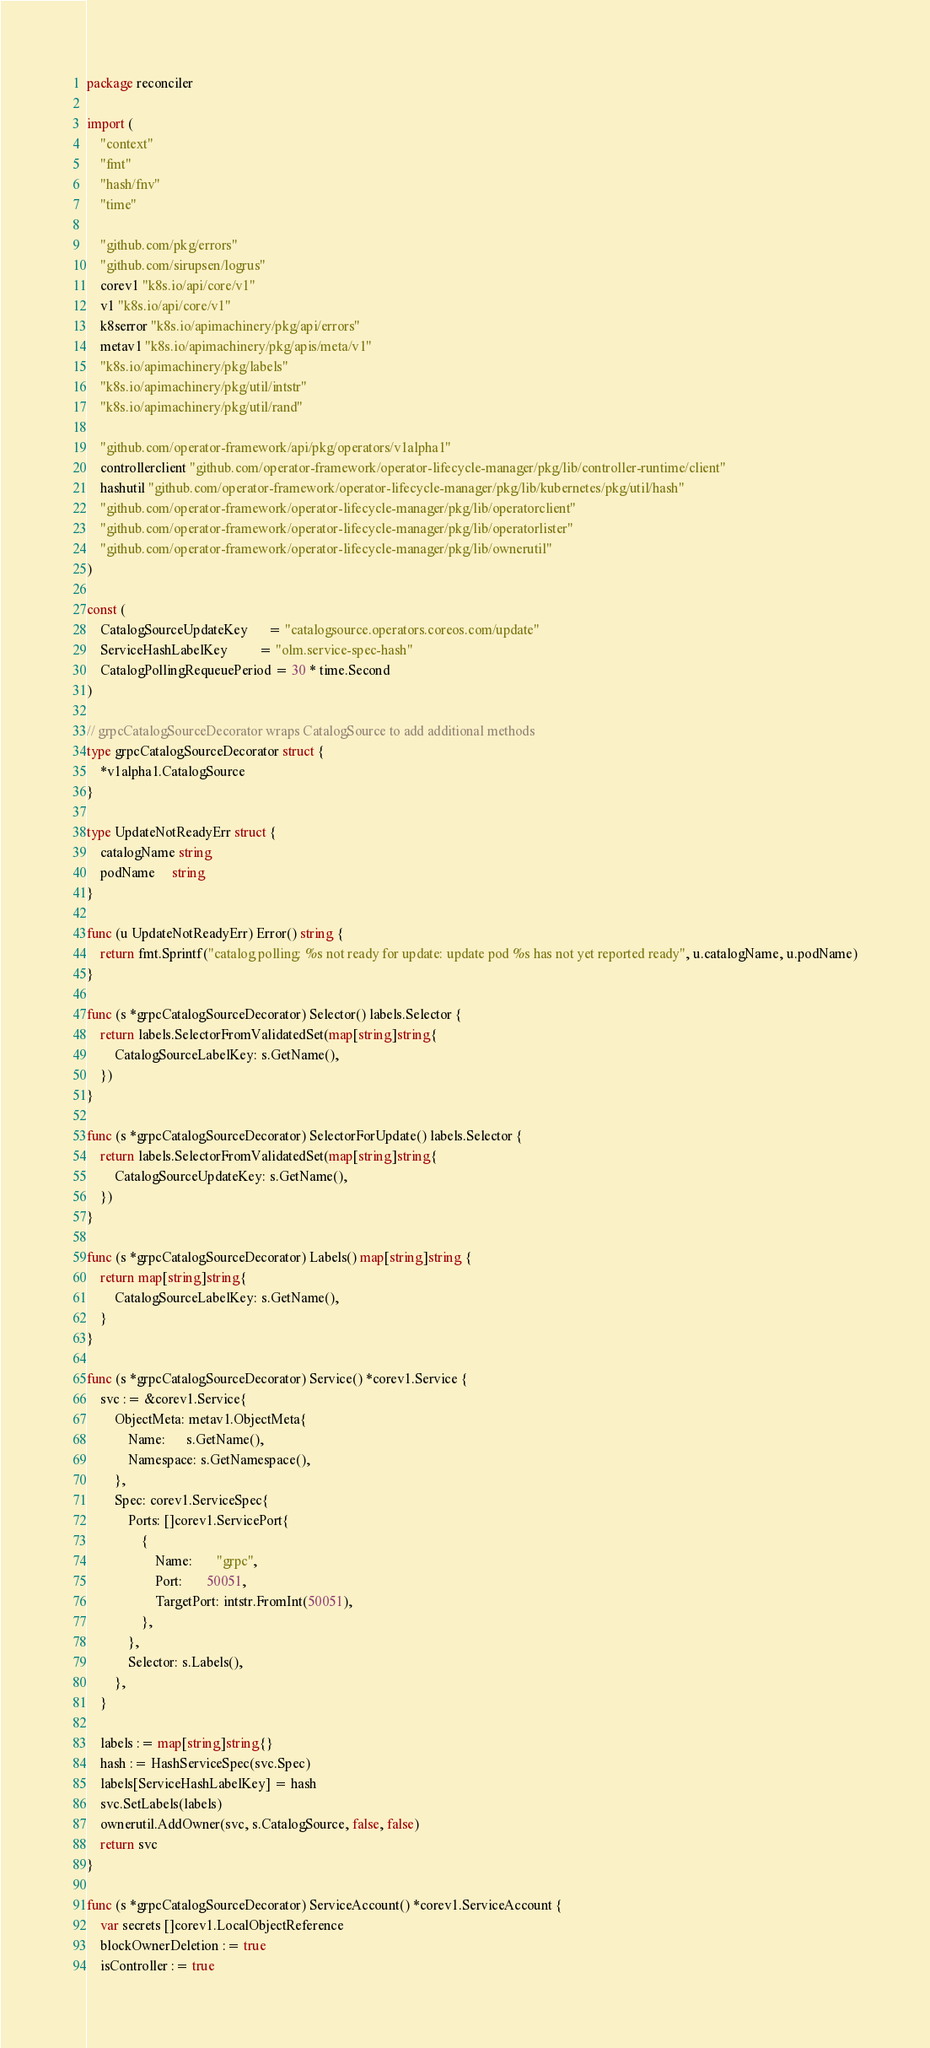<code> <loc_0><loc_0><loc_500><loc_500><_Go_>package reconciler

import (
	"context"
	"fmt"
	"hash/fnv"
	"time"

	"github.com/pkg/errors"
	"github.com/sirupsen/logrus"
	corev1 "k8s.io/api/core/v1"
	v1 "k8s.io/api/core/v1"
	k8serror "k8s.io/apimachinery/pkg/api/errors"
	metav1 "k8s.io/apimachinery/pkg/apis/meta/v1"
	"k8s.io/apimachinery/pkg/labels"
	"k8s.io/apimachinery/pkg/util/intstr"
	"k8s.io/apimachinery/pkg/util/rand"

	"github.com/operator-framework/api/pkg/operators/v1alpha1"
	controllerclient "github.com/operator-framework/operator-lifecycle-manager/pkg/lib/controller-runtime/client"
	hashutil "github.com/operator-framework/operator-lifecycle-manager/pkg/lib/kubernetes/pkg/util/hash"
	"github.com/operator-framework/operator-lifecycle-manager/pkg/lib/operatorclient"
	"github.com/operator-framework/operator-lifecycle-manager/pkg/lib/operatorlister"
	"github.com/operator-framework/operator-lifecycle-manager/pkg/lib/ownerutil"
)

const (
	CatalogSourceUpdateKey      = "catalogsource.operators.coreos.com/update"
	ServiceHashLabelKey         = "olm.service-spec-hash"
	CatalogPollingRequeuePeriod = 30 * time.Second
)

// grpcCatalogSourceDecorator wraps CatalogSource to add additional methods
type grpcCatalogSourceDecorator struct {
	*v1alpha1.CatalogSource
}

type UpdateNotReadyErr struct {
	catalogName string
	podName     string
}

func (u UpdateNotReadyErr) Error() string {
	return fmt.Sprintf("catalog polling: %s not ready for update: update pod %s has not yet reported ready", u.catalogName, u.podName)
}

func (s *grpcCatalogSourceDecorator) Selector() labels.Selector {
	return labels.SelectorFromValidatedSet(map[string]string{
		CatalogSourceLabelKey: s.GetName(),
	})
}

func (s *grpcCatalogSourceDecorator) SelectorForUpdate() labels.Selector {
	return labels.SelectorFromValidatedSet(map[string]string{
		CatalogSourceUpdateKey: s.GetName(),
	})
}

func (s *grpcCatalogSourceDecorator) Labels() map[string]string {
	return map[string]string{
		CatalogSourceLabelKey: s.GetName(),
	}
}

func (s *grpcCatalogSourceDecorator) Service() *corev1.Service {
	svc := &corev1.Service{
		ObjectMeta: metav1.ObjectMeta{
			Name:      s.GetName(),
			Namespace: s.GetNamespace(),
		},
		Spec: corev1.ServiceSpec{
			Ports: []corev1.ServicePort{
				{
					Name:       "grpc",
					Port:       50051,
					TargetPort: intstr.FromInt(50051),
				},
			},
			Selector: s.Labels(),
		},
	}

	labels := map[string]string{}
	hash := HashServiceSpec(svc.Spec)
	labels[ServiceHashLabelKey] = hash
	svc.SetLabels(labels)
	ownerutil.AddOwner(svc, s.CatalogSource, false, false)
	return svc
}

func (s *grpcCatalogSourceDecorator) ServiceAccount() *corev1.ServiceAccount {
	var secrets []corev1.LocalObjectReference
	blockOwnerDeletion := true
	isController := true</code> 